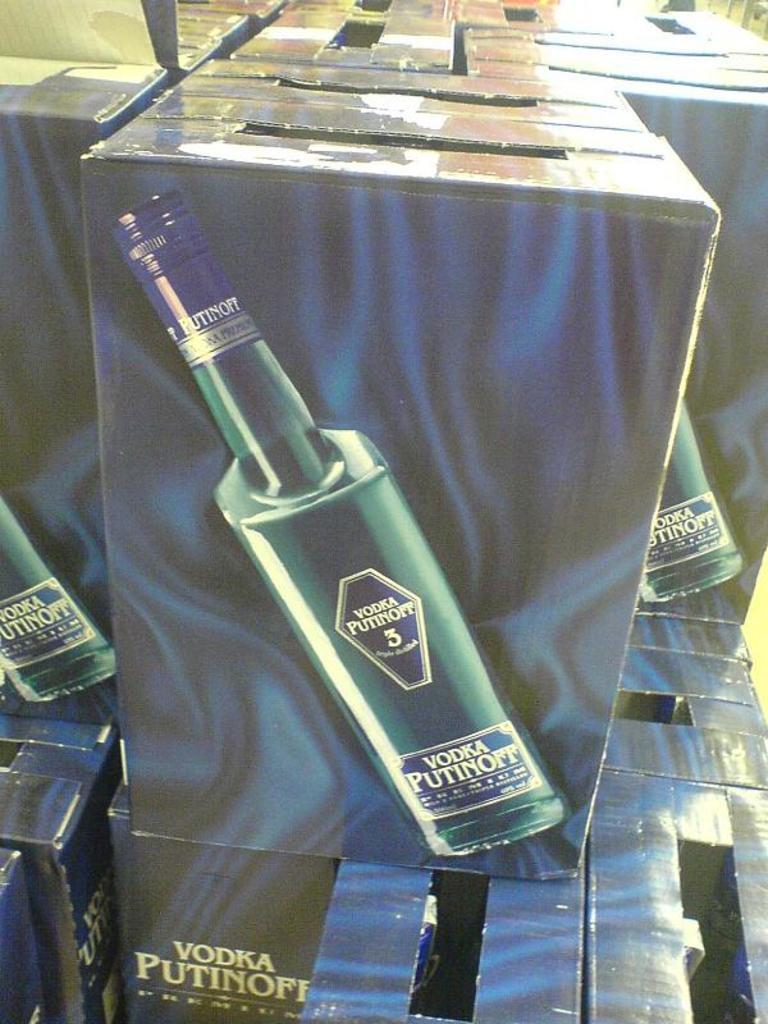Provide a one-sentence caption for the provided image. A bottle of Vodka Putinoff is shows on the side of a cardboard box. 